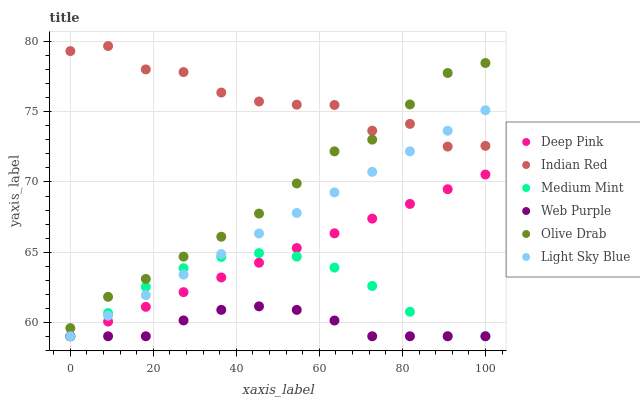Does Web Purple have the minimum area under the curve?
Answer yes or no. Yes. Does Indian Red have the maximum area under the curve?
Answer yes or no. Yes. Does Deep Pink have the minimum area under the curve?
Answer yes or no. No. Does Deep Pink have the maximum area under the curve?
Answer yes or no. No. Is Deep Pink the smoothest?
Answer yes or no. Yes. Is Indian Red the roughest?
Answer yes or no. Yes. Is Web Purple the smoothest?
Answer yes or no. No. Is Web Purple the roughest?
Answer yes or no. No. Does Medium Mint have the lowest value?
Answer yes or no. Yes. Does Indian Red have the lowest value?
Answer yes or no. No. Does Indian Red have the highest value?
Answer yes or no. Yes. Does Deep Pink have the highest value?
Answer yes or no. No. Is Web Purple less than Indian Red?
Answer yes or no. Yes. Is Olive Drab greater than Light Sky Blue?
Answer yes or no. Yes. Does Web Purple intersect Medium Mint?
Answer yes or no. Yes. Is Web Purple less than Medium Mint?
Answer yes or no. No. Is Web Purple greater than Medium Mint?
Answer yes or no. No. Does Web Purple intersect Indian Red?
Answer yes or no. No. 